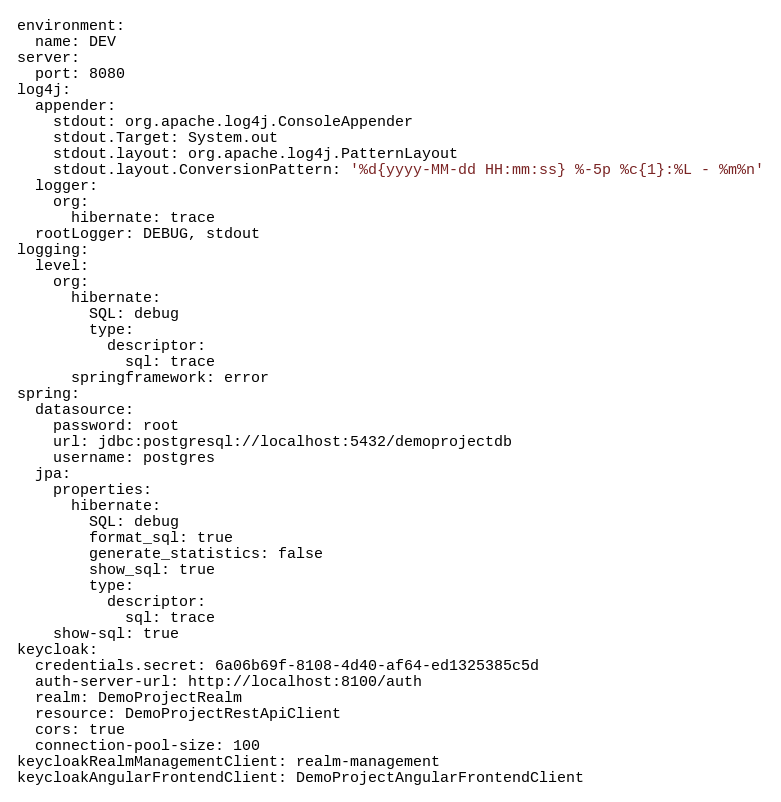Convert code to text. <code><loc_0><loc_0><loc_500><loc_500><_YAML_>environment:
  name: DEV
server:
  port: 8080
log4j:
  appender:
    stdout: org.apache.log4j.ConsoleAppender
    stdout.Target: System.out
    stdout.layout: org.apache.log4j.PatternLayout
    stdout.layout.ConversionPattern: '%d{yyyy-MM-dd HH:mm:ss} %-5p %c{1}:%L - %m%n'
  logger:
    org:
      hibernate: trace
  rootLogger: DEBUG, stdout
logging:
  level:
    org:
      hibernate:
        SQL: debug
        type:
          descriptor:
            sql: trace
      springframework: error
spring:
  datasource:
    password: root
    url: jdbc:postgresql://localhost:5432/demoprojectdb
    username: postgres
  jpa:
    properties:
      hibernate:
        SQL: debug
        format_sql: true
        generate_statistics: false
        show_sql: true
        type:
          descriptor:
            sql: trace
    show-sql: true
keycloak:
  credentials.secret: 6a06b69f-8108-4d40-af64-ed1325385c5d
  auth-server-url: http://localhost:8100/auth
  realm: DemoProjectRealm
  resource: DemoProjectRestApiClient
  cors: true
  connection-pool-size: 100
keycloakRealmManagementClient: realm-management
keycloakAngularFrontendClient: DemoProjectAngularFrontendClient

</code> 